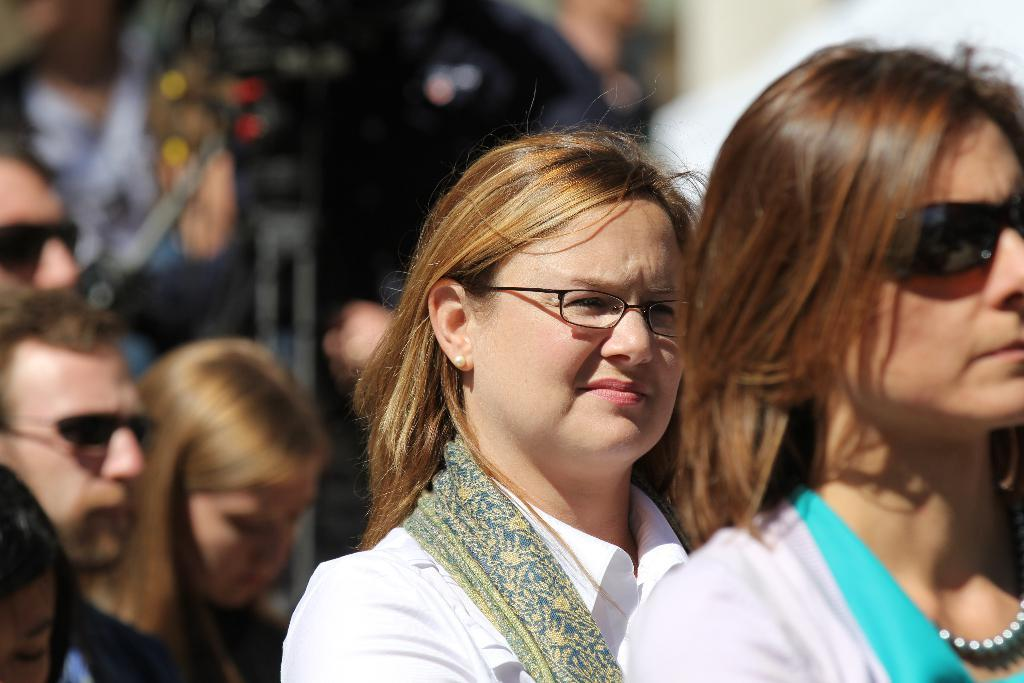What is happening in the image? There are people standing in the image. Can you describe any objects or equipment visible in the image? There appears to be a camera on a stand in the background of the image. What type of toothbrush is being used during the feast in the image? There is no toothbrush or feast present in the image. 